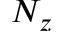Convert formula to latex. <formula><loc_0><loc_0><loc_500><loc_500>N _ { z }</formula> 